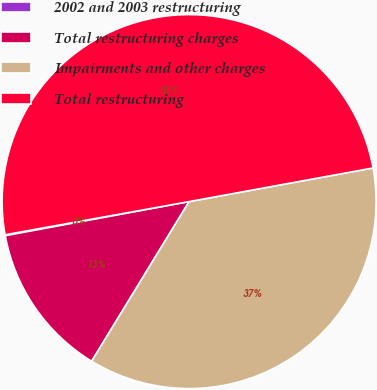Convert chart. <chart><loc_0><loc_0><loc_500><loc_500><pie_chart><fcel>2002 and 2003 restructuring<fcel>Total restructuring charges<fcel>Impairments and other charges<fcel>Total restructuring<nl><fcel>0.08%<fcel>13.36%<fcel>36.6%<fcel>49.96%<nl></chart> 